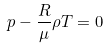Convert formula to latex. <formula><loc_0><loc_0><loc_500><loc_500>p - \frac { R } { \mu } \rho T = 0</formula> 